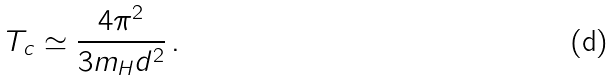Convert formula to latex. <formula><loc_0><loc_0><loc_500><loc_500>T _ { c } \simeq \frac { 4 \pi ^ { 2 } } { 3 m _ { H } d ^ { 2 } } \, .</formula> 